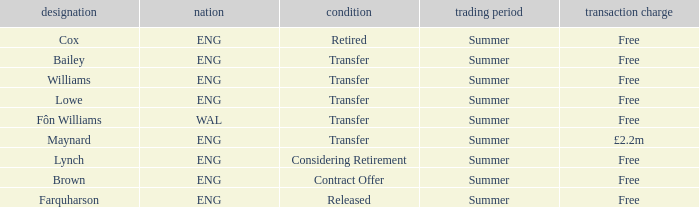What is Brown's transfer window? Summer. 